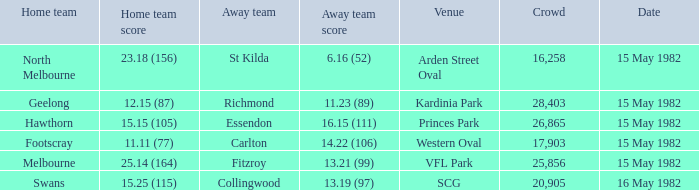Which guest team had in excess of 17,903 viewers and played against melbourne? 13.21 (99). 